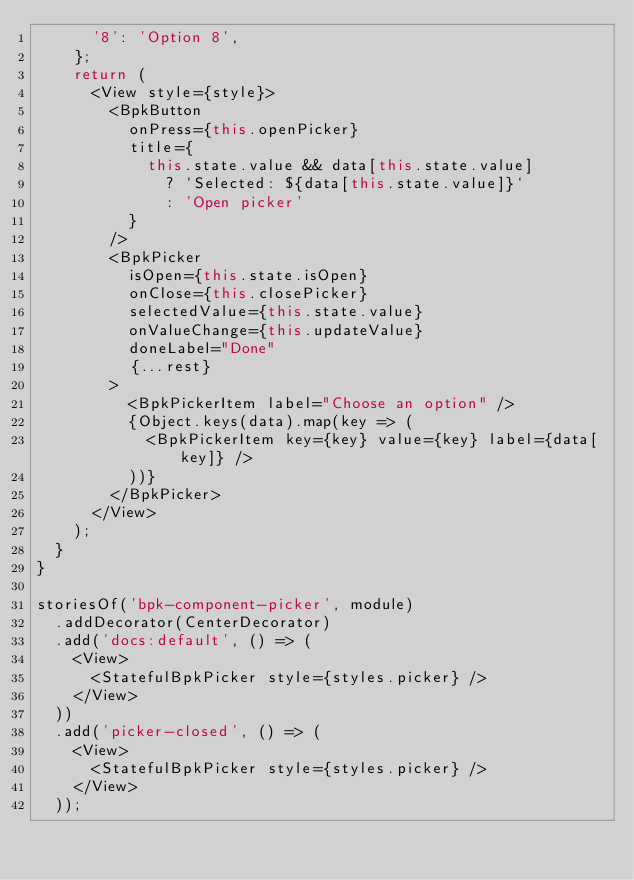<code> <loc_0><loc_0><loc_500><loc_500><_JavaScript_>      '8': 'Option 8',
    };
    return (
      <View style={style}>
        <BpkButton
          onPress={this.openPicker}
          title={
            this.state.value && data[this.state.value]
              ? `Selected: ${data[this.state.value]}`
              : 'Open picker'
          }
        />
        <BpkPicker
          isOpen={this.state.isOpen}
          onClose={this.closePicker}
          selectedValue={this.state.value}
          onValueChange={this.updateValue}
          doneLabel="Done"
          {...rest}
        >
          <BpkPickerItem label="Choose an option" />
          {Object.keys(data).map(key => (
            <BpkPickerItem key={key} value={key} label={data[key]} />
          ))}
        </BpkPicker>
      </View>
    );
  }
}

storiesOf('bpk-component-picker', module)
  .addDecorator(CenterDecorator)
  .add('docs:default', () => (
    <View>
      <StatefulBpkPicker style={styles.picker} />
    </View>
  ))
  .add('picker-closed', () => (
    <View>
      <StatefulBpkPicker style={styles.picker} />
    </View>
  ));
</code> 